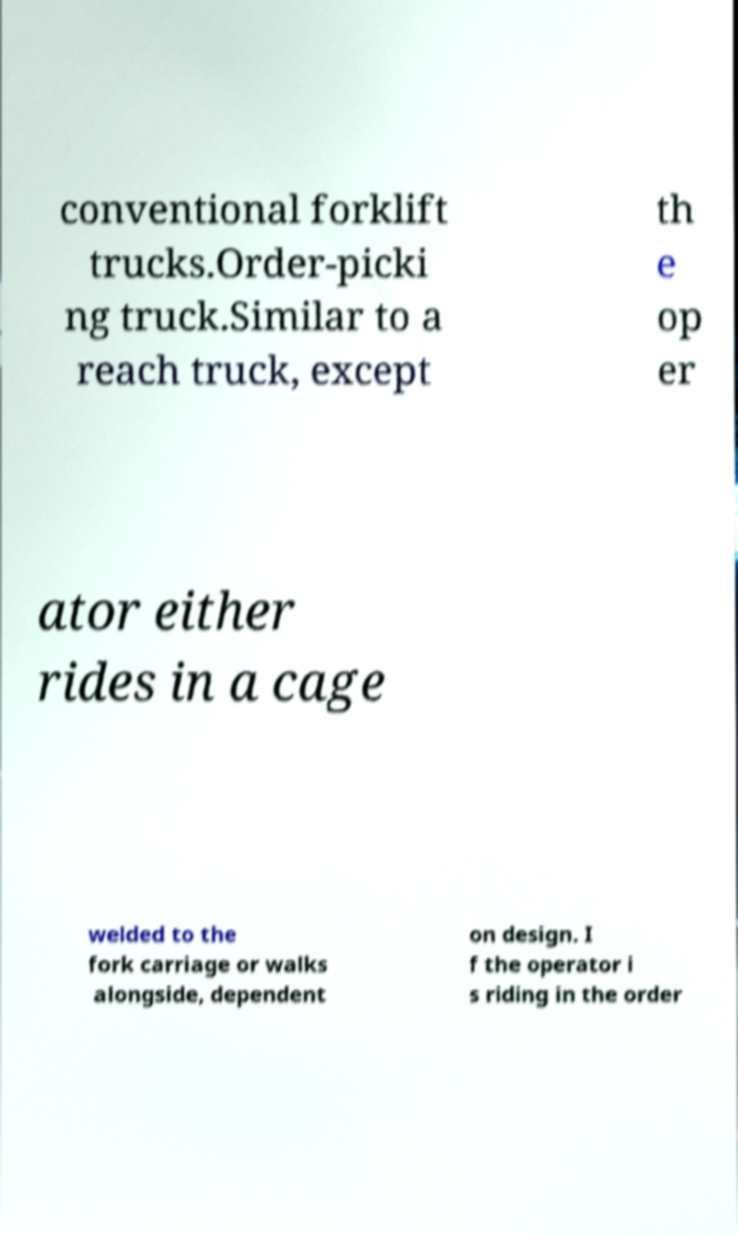Can you accurately transcribe the text from the provided image for me? conventional forklift trucks.Order-picki ng truck.Similar to a reach truck, except th e op er ator either rides in a cage welded to the fork carriage or walks alongside, dependent on design. I f the operator i s riding in the order 